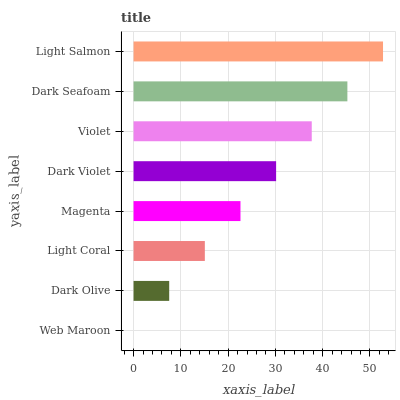Is Web Maroon the minimum?
Answer yes or no. Yes. Is Light Salmon the maximum?
Answer yes or no. Yes. Is Dark Olive the minimum?
Answer yes or no. No. Is Dark Olive the maximum?
Answer yes or no. No. Is Dark Olive greater than Web Maroon?
Answer yes or no. Yes. Is Web Maroon less than Dark Olive?
Answer yes or no. Yes. Is Web Maroon greater than Dark Olive?
Answer yes or no. No. Is Dark Olive less than Web Maroon?
Answer yes or no. No. Is Dark Violet the high median?
Answer yes or no. Yes. Is Magenta the low median?
Answer yes or no. Yes. Is Light Salmon the high median?
Answer yes or no. No. Is Dark Violet the low median?
Answer yes or no. No. 